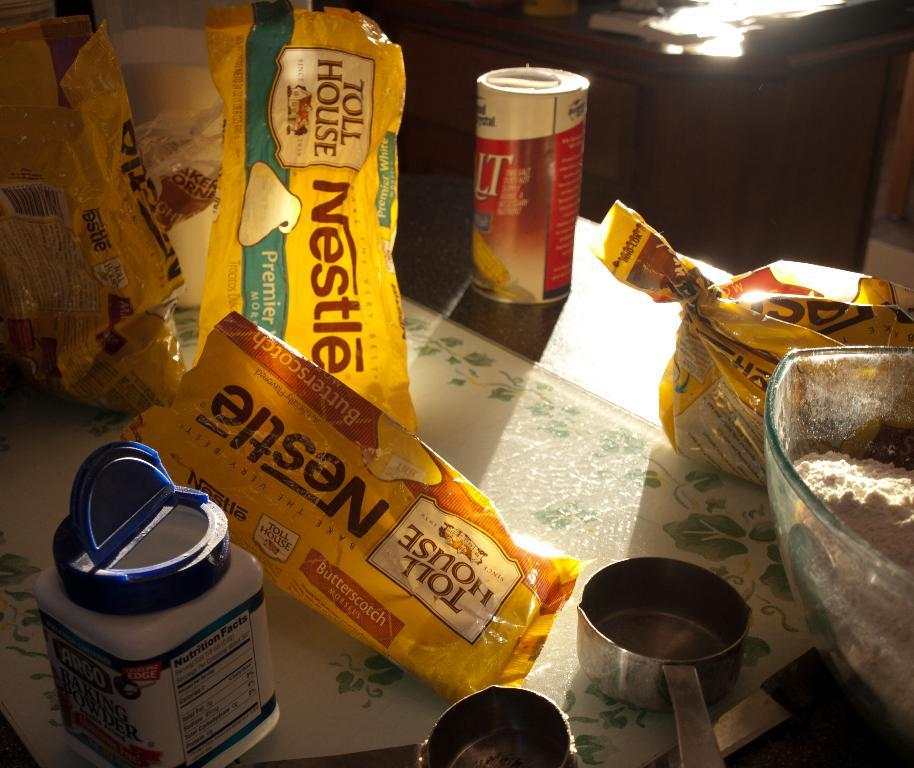Provide a one-sentence caption for the provided image. someone's packaging who loves Nestle Tollhouse morsels. 